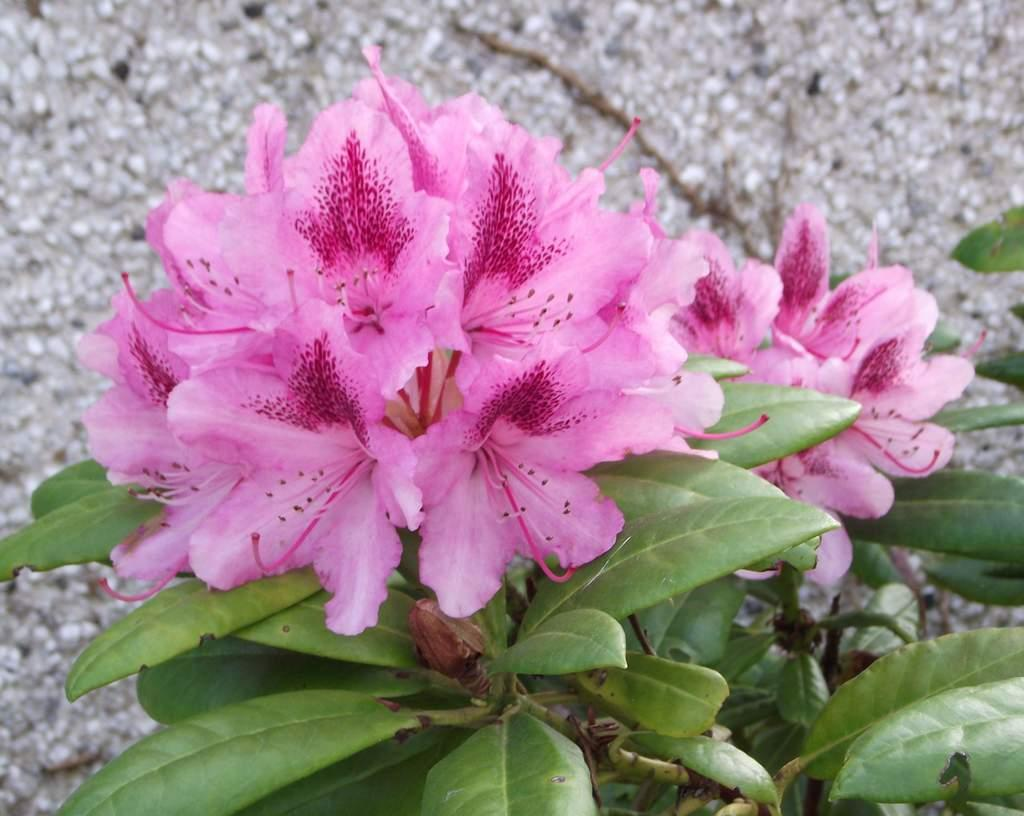What type of living organisms can be seen in the image? Flowers and plants are visible in the image. What type of inanimate objects can be seen in the image? Small stones are visible in the image. How many spiders can be seen crawling on the flowers in the image? There are no spiders visible in the image; it only features flowers, plants, and small stones. What type of religious building can be seen in the image? There is no religious building, such as a church, present in the image. 